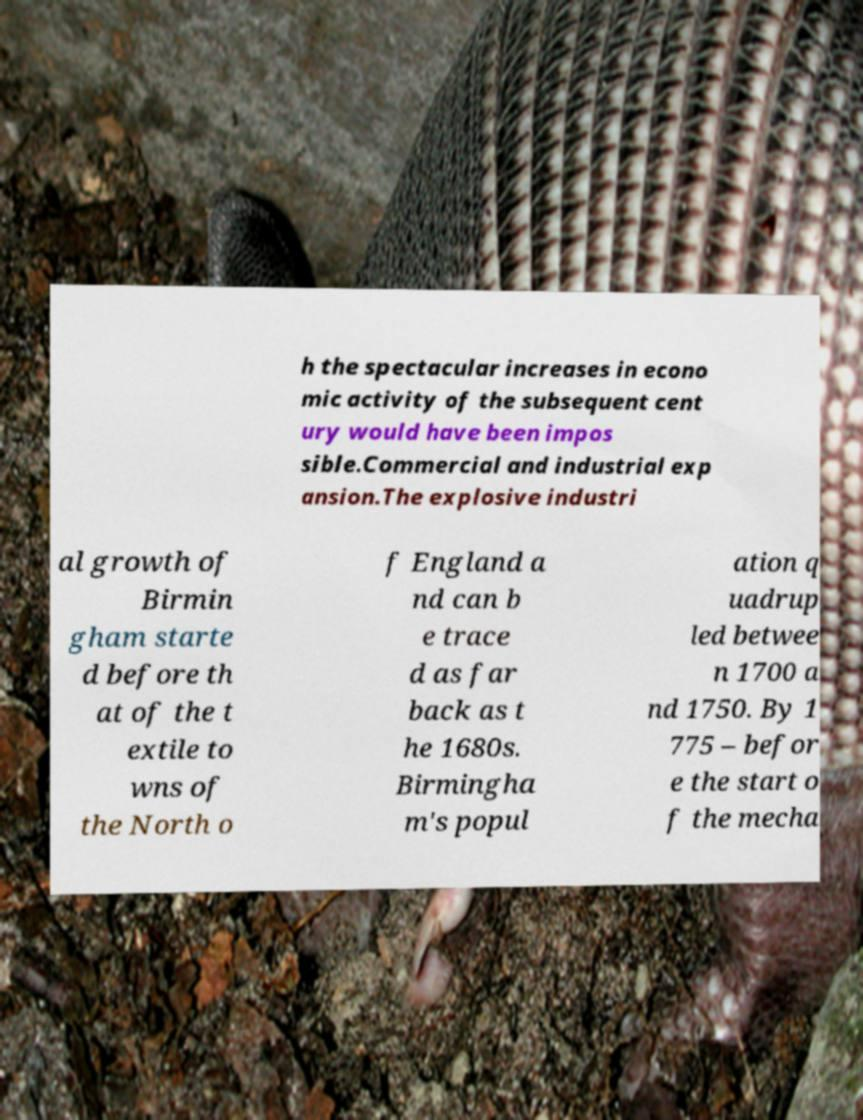Can you read and provide the text displayed in the image?This photo seems to have some interesting text. Can you extract and type it out for me? h the spectacular increases in econo mic activity of the subsequent cent ury would have been impos sible.Commercial and industrial exp ansion.The explosive industri al growth of Birmin gham starte d before th at of the t extile to wns of the North o f England a nd can b e trace d as far back as t he 1680s. Birmingha m's popul ation q uadrup led betwee n 1700 a nd 1750. By 1 775 – befor e the start o f the mecha 